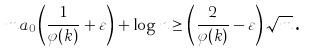Convert formula to latex. <formula><loc_0><loc_0><loc_500><loc_500>m a _ { 0 } \left ( \frac { 1 } { \varphi ( k ) } + \varepsilon \right ) + \log n \geq \left ( \frac { 2 } { \varphi ( k ) } - \varepsilon \right ) \sqrt { m } { \text {.} }</formula> 